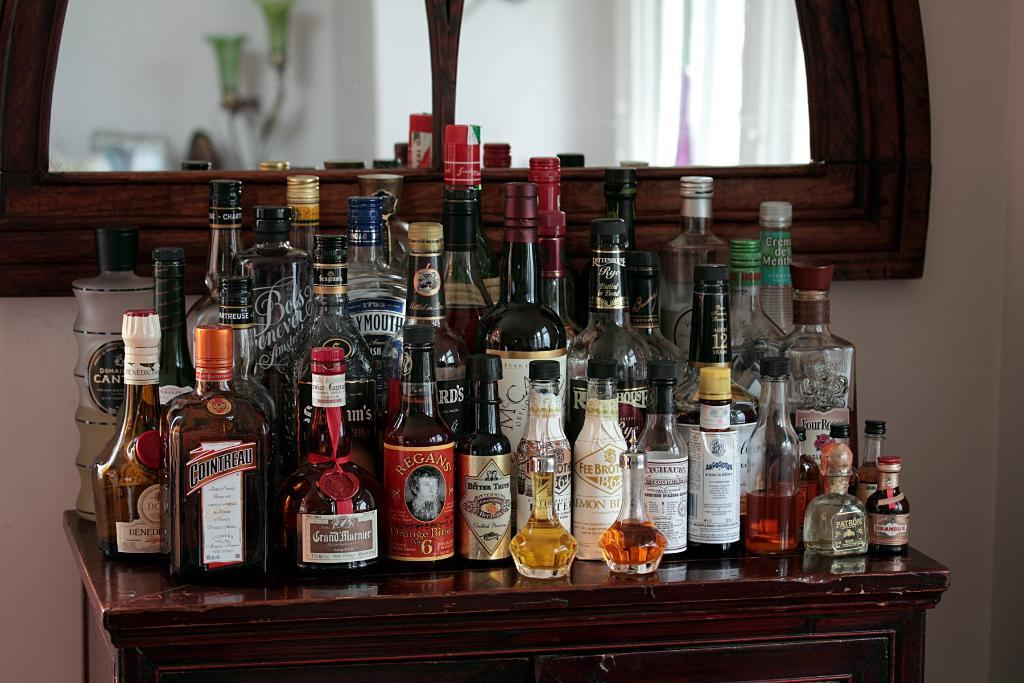<image>
Create a compact narrative representing the image presented. bottles of liquor like Cointreau line a table 